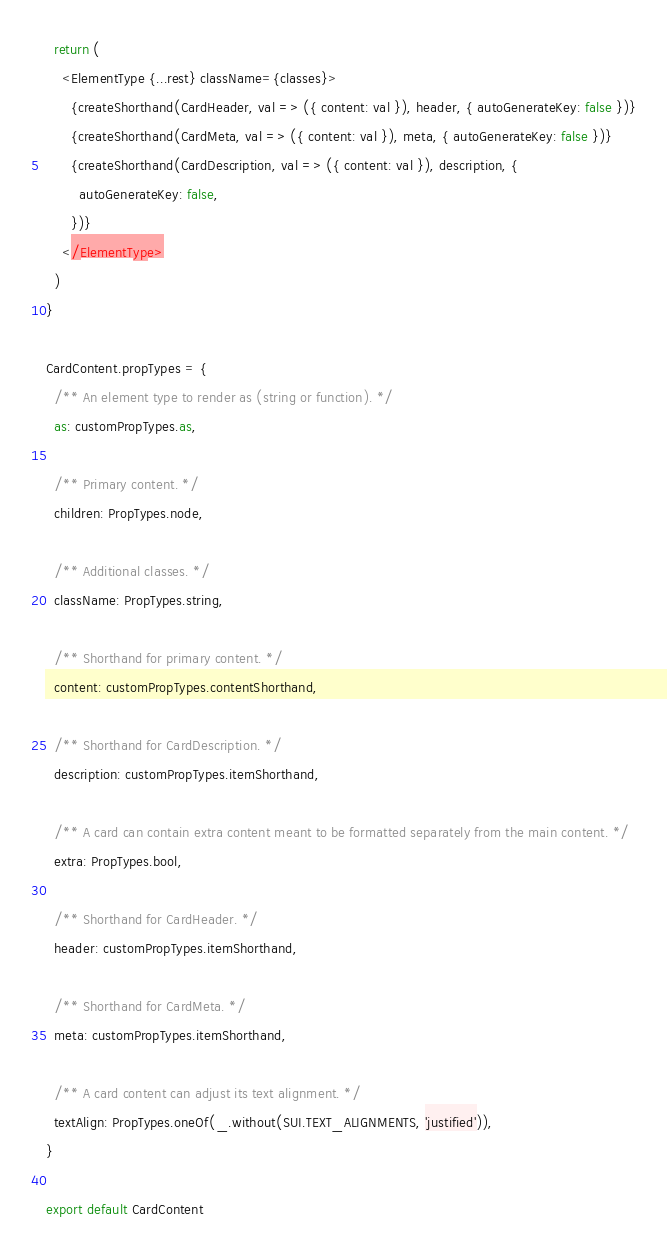<code> <loc_0><loc_0><loc_500><loc_500><_JavaScript_>  return (
    <ElementType {...rest} className={classes}>
      {createShorthand(CardHeader, val => ({ content: val }), header, { autoGenerateKey: false })}
      {createShorthand(CardMeta, val => ({ content: val }), meta, { autoGenerateKey: false })}
      {createShorthand(CardDescription, val => ({ content: val }), description, {
        autoGenerateKey: false,
      })}
    </ElementType>
  )
}

CardContent.propTypes = {
  /** An element type to render as (string or function). */
  as: customPropTypes.as,

  /** Primary content. */
  children: PropTypes.node,

  /** Additional classes. */
  className: PropTypes.string,

  /** Shorthand for primary content. */
  content: customPropTypes.contentShorthand,

  /** Shorthand for CardDescription. */
  description: customPropTypes.itemShorthand,

  /** A card can contain extra content meant to be formatted separately from the main content. */
  extra: PropTypes.bool,

  /** Shorthand for CardHeader. */
  header: customPropTypes.itemShorthand,

  /** Shorthand for CardMeta. */
  meta: customPropTypes.itemShorthand,

  /** A card content can adjust its text alignment. */
  textAlign: PropTypes.oneOf(_.without(SUI.TEXT_ALIGNMENTS, 'justified')),
}

export default CardContent
</code> 